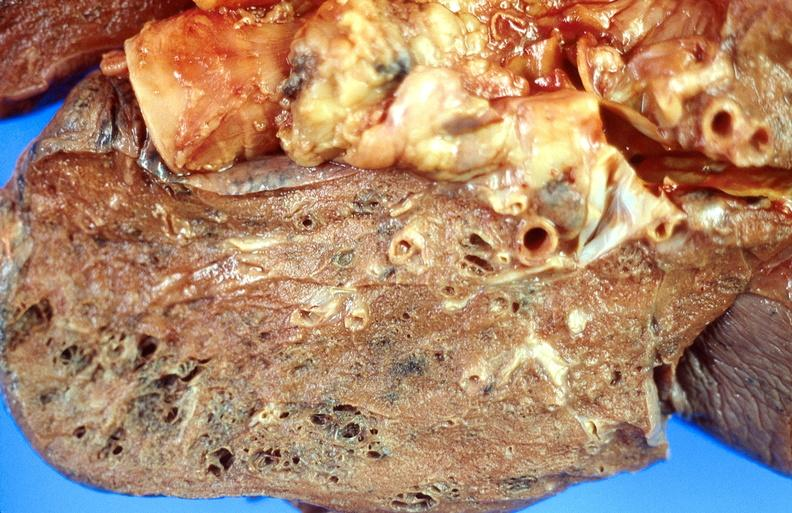does this image show cryptococcal pneumonia?
Answer the question using a single word or phrase. Yes 